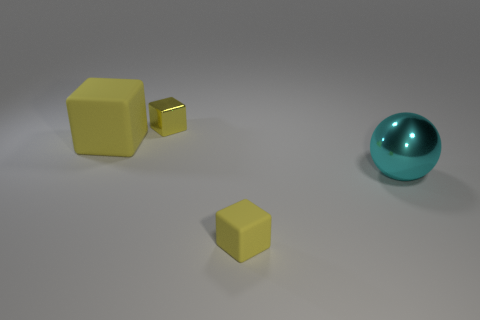Add 2 large spheres. How many objects exist? 6 Subtract all spheres. How many objects are left? 3 Subtract all big shiny things. Subtract all large spheres. How many objects are left? 2 Add 3 large things. How many large things are left? 5 Add 3 blue spheres. How many blue spheres exist? 3 Subtract 0 blue cylinders. How many objects are left? 4 